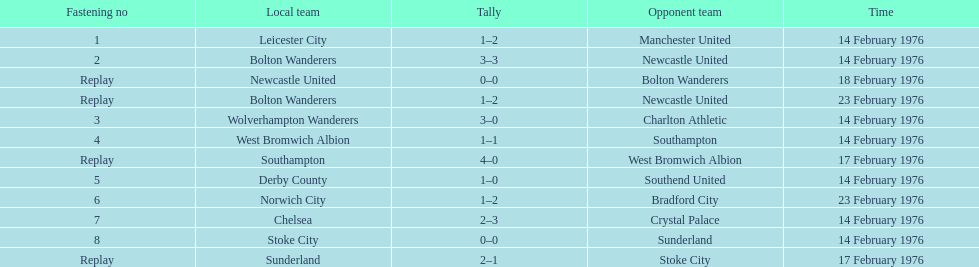What was the goal difference in the game on february 18th? 0. 